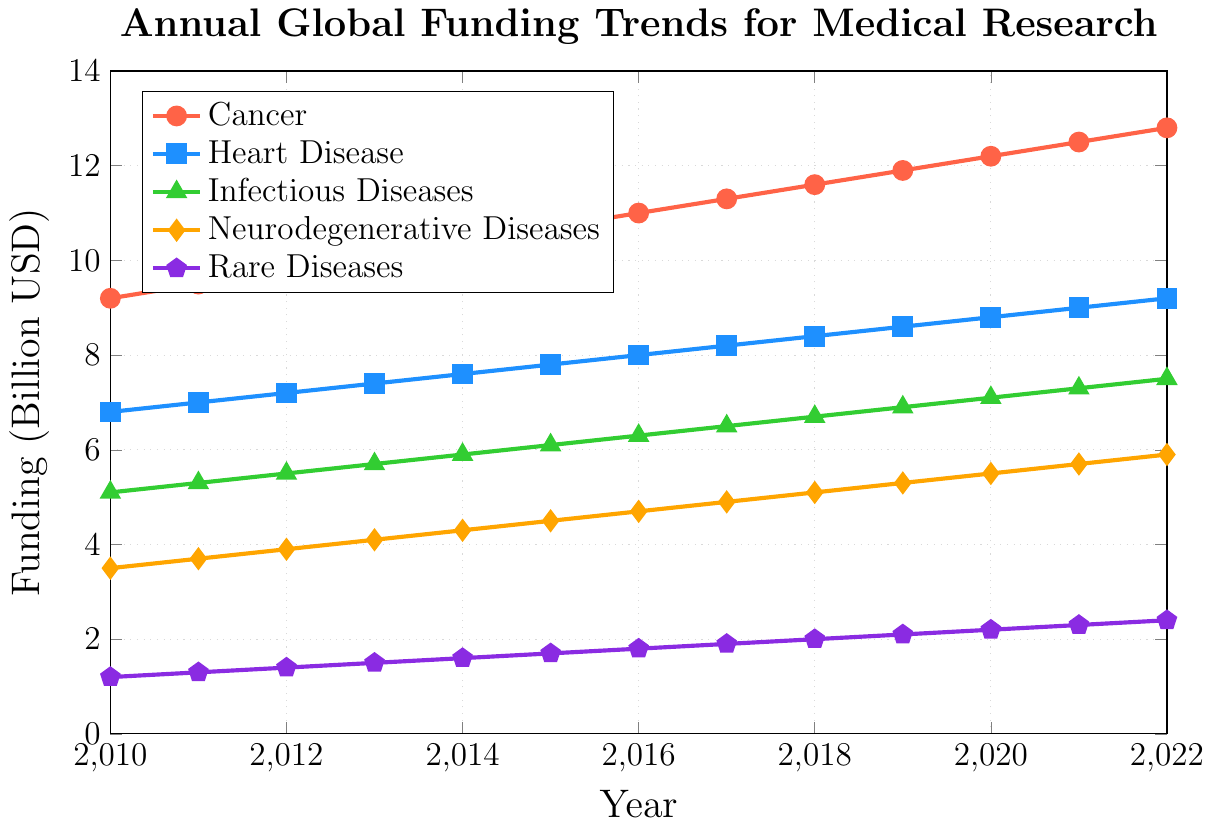What is the general trend for Cancer research funding from 2010 to 2022? The graph shows a steady increase in funding for Cancer research from 9.2 billion USD in 2010 to 12.8 billion USD in 2022.
Answer: Steady increase Which disease had the highest funding in 2015? By comparing the points on the lines for 2015, Cancer research had the highest funding at 10.7 billion USD.
Answer: Cancer How much did funding for Heart Disease increase from 2010 to 2022? The funding for Heart Disease in 2010 was 6.8 billion USD, and in 2022 it was 9.2 billion USD. The increase is 9.2 - 6.8 = 2.4 billion USD.
Answer: 2.4 billion USD By how much did funding for Neurodegenerative Diseases increase between 2013 and 2018? In 2013, funding for Neurodegenerative Diseases was 4.1 billion USD. In 2018, it was 5.1 billion USD. The increase is 5.1 - 4.1 = 1.0 billion USD.
Answer: 1.0 billion USD Which disease had the least amount of funding in 2022? By checking the end points for 2022, Rare Diseases had the least funding at 2.4 billion USD.
Answer: Rare Diseases Compare the rate of increase in funding for Infectious Diseases and Neurodegenerative Diseases from 2010 to 2022. Infectious Diseases funding increased from 5.1 to 7.5 billion USD, a difference of 2.4 billion USD. Neurodegenerative Diseases funding increased from 3.5 to 5.9 billion USD, a difference of 2.4 billion USD. Both had the same rate of increase in terms of absolute funding, 2.4 billion USD.
Answer: Same rate of increase Which disease shows the most consistent annual increase in funding? By observing the slopes of the lines, all diseases have a consistent increase, but Cancer and Heart Disease seem to show the most linear and consistent increases. Between the two, Cancer has a slight edge in consistency.
Answer: Cancer What was the average funding for Rare Diseases over the years shown in the graph? To find the average funding for Rare Diseases, sum all the yearly funding values and divide by the number of years: (1.2 + 1.3 + 1.4 + 1.5 + 1.6 + 1.7 + 1.8 + 1.9 + 2.0 + 2.1 + 2.2 + 2.3 + 2.4) / 13. This sum is 22.4, so the average is 22.4 / 13 ≈ 1.72 billion USD.
Answer: 1.72 billion USD What was the total funding for Cancer and Heart Disease research in 2020? Add the funding for Cancer and Heart Disease in 2020: 12.2 (Cancer) + 8.8 (Heart Disease) = 21.0 billion USD.
Answer: 21.0 billion USD 